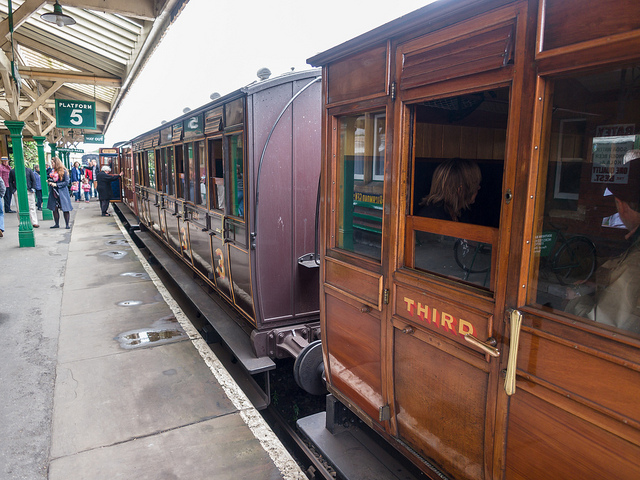Read all the text in this image. PLATFORM 5 THIRD 